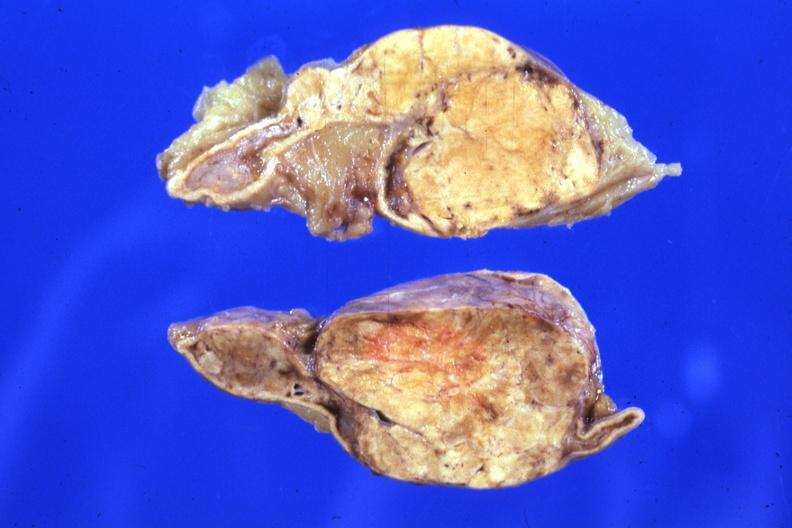s adrenal present?
Answer the question using a single word or phrase. Yes 